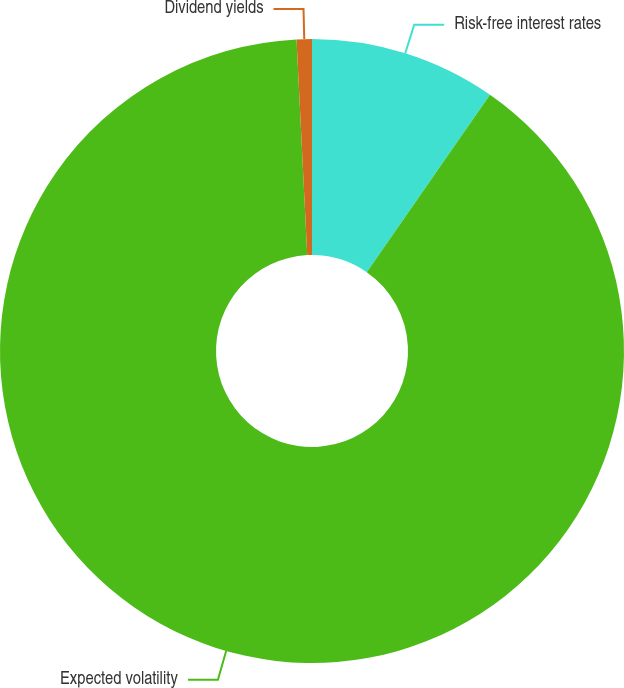Convert chart. <chart><loc_0><loc_0><loc_500><loc_500><pie_chart><fcel>Risk-free interest rates<fcel>Expected volatility<fcel>Dividend yields<nl><fcel>9.66%<fcel>89.54%<fcel>0.79%<nl></chart> 